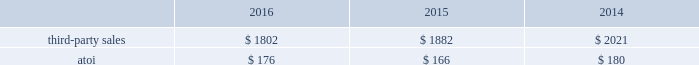Third-party sales for the engineered products and solutions segment improved 7% ( 7 % ) in 2016 compared with 2015 , primarily attributable to higher third-party sales of the two acquired businesses ( $ 457 ) , primarily related to the aerospace end market , and increased demand from the industrial gas turbine end market , partially offset by lower volumes in the oil and gas end market and commercial transportation end market as well as pricing pressures in aerospace .
Third-party sales for this segment improved 27% ( 27 % ) in 2015 compared with 2014 , largely attributable to the third-party sales ( $ 1310 ) of the three acquired businesses ( see above ) , and higher volumes in this segment 2019s legacy businesses , both of which were primarily related to the aerospace end market .
These positive impacts were slightly offset by unfavorable foreign currency movements , principally driven by a weaker euro .
Atoi for the engineered products and solutions segment increased $ 47 , or 8% ( 8 % ) , in 2016 compared with 2015 , primarily related to net productivity improvements across all businesses as well as the volume increase from both the rti acquisition and organic revenue growth , partially offset by a lower margin product mix and pricing pressures in the aerospace end market .
Atoi for this segment increased $ 16 , or 3% ( 3 % ) , in 2015 compared with 2014 , principally the result of net productivity improvements across most businesses , a positive contribution from acquisitions , and overall higher volumes in this segment 2019s legacy businesses .
These positive impacts were partially offset by unfavorable price and product mix , higher costs related to growth projects , and net unfavorable foreign currency movements , primarily related to a weaker euro .
In 2017 , demand in the commercial aerospace end market is expected to remain strong , driven by the ramp up of new aerospace engine platforms , somewhat offset by continued customer destocking and engine ramp-up challenges .
Demand in the defense end market is expected to grow due to the continuing ramp-up of certain aerospace programs .
Additionally , net productivity improvements are anticipated while pricing pressure across all markets is likely to continue .
Transportation and construction solutions .
The transportation and construction solutions segment produces products that are used mostly in the nonresidential building and construction and commercial transportation end markets .
Such products include integrated aluminum structural systems , architectural extrusions , and forged aluminum commercial vehicle wheels , which are sold both directly to customers and through distributors .
A small part of this segment also produces aluminum products for the industrial products end market .
Generally , the sales and costs and expenses of this segment are transacted in the local currency of the respective operations , which are primarily the u.s .
Dollar , the euro , and the brazilian real .
Third-party sales for the transportation and construction solutions segment decreased 4% ( 4 % ) in 2016 compared with 2015 , primarily driven by lower demand from the north american commercial transportation end market , which was partially offset by rising demand from the building and construction end market .
Third-party sales for this segment decreased 7% ( 7 % ) in 2015 compared with 2014 , primarily driven by unfavorable foreign currency movements , principally caused by a weaker euro and brazilian real , and lower volume related to the building and construction end market , somewhat offset by higher volume related to the commercial transportation end market .
Atoi for the transportation and construction solutions segment increased $ 10 , or 6% ( 6 % ) , in 2016 compared with 2015 , principally driven by net productivity improvements across all businesses and growth in the building and construction segment , partially offset by lower demand in the north american heavy duty truck and brazilian markets. .
Considering the years 2015-2016 , how bigger is the growth of the third-party sales for the engineered products and solutions segment in comparison with the transportation and construction solutions one? 
Rationale: it is the difference between the percentual variation of the third-party sales of both segments .
Computations: (7% - ((1802 - 1882) / 1882))
Answer: 0.11251. 